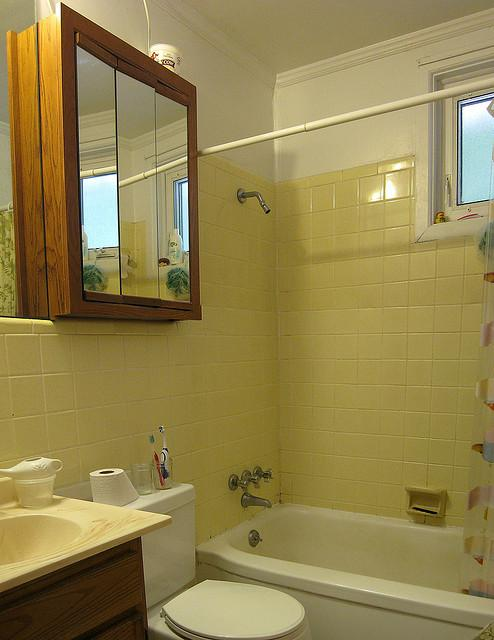Why is the toilet paper on the toilet tank? no holder 